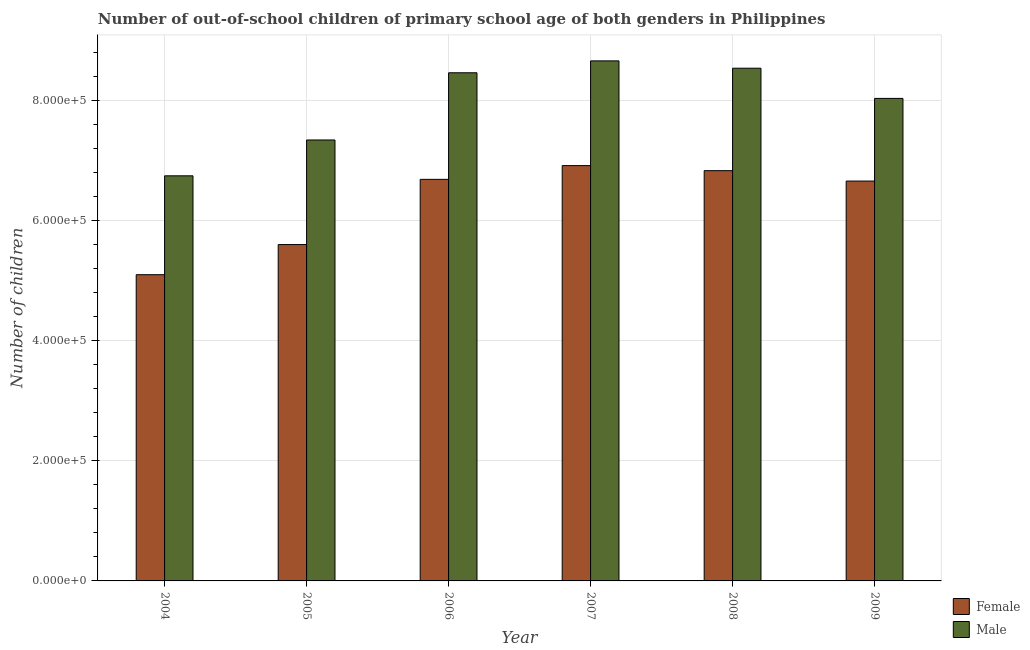How many different coloured bars are there?
Keep it short and to the point. 2. Are the number of bars per tick equal to the number of legend labels?
Provide a short and direct response. Yes. How many bars are there on the 2nd tick from the left?
Keep it short and to the point. 2. What is the number of female out-of-school students in 2004?
Offer a terse response. 5.10e+05. Across all years, what is the maximum number of male out-of-school students?
Offer a terse response. 8.66e+05. Across all years, what is the minimum number of male out-of-school students?
Offer a very short reply. 6.74e+05. In which year was the number of male out-of-school students maximum?
Provide a succinct answer. 2007. What is the total number of male out-of-school students in the graph?
Your answer should be compact. 4.78e+06. What is the difference between the number of male out-of-school students in 2004 and that in 2005?
Make the answer very short. -5.97e+04. What is the difference between the number of male out-of-school students in 2005 and the number of female out-of-school students in 2004?
Your answer should be compact. 5.97e+04. What is the average number of female out-of-school students per year?
Give a very brief answer. 6.30e+05. In how many years, is the number of male out-of-school students greater than 440000?
Your response must be concise. 6. What is the ratio of the number of male out-of-school students in 2004 to that in 2005?
Offer a very short reply. 0.92. Is the number of female out-of-school students in 2006 less than that in 2009?
Make the answer very short. No. What is the difference between the highest and the second highest number of female out-of-school students?
Keep it short and to the point. 8438. What is the difference between the highest and the lowest number of female out-of-school students?
Ensure brevity in your answer.  1.82e+05. Is the sum of the number of female out-of-school students in 2005 and 2009 greater than the maximum number of male out-of-school students across all years?
Your response must be concise. Yes. What does the 1st bar from the left in 2009 represents?
Your answer should be compact. Female. How many years are there in the graph?
Provide a short and direct response. 6. Are the values on the major ticks of Y-axis written in scientific E-notation?
Your response must be concise. Yes. Does the graph contain grids?
Your response must be concise. Yes. How many legend labels are there?
Provide a short and direct response. 2. How are the legend labels stacked?
Provide a succinct answer. Vertical. What is the title of the graph?
Your answer should be very brief. Number of out-of-school children of primary school age of both genders in Philippines. Does "Research and Development" appear as one of the legend labels in the graph?
Ensure brevity in your answer.  No. What is the label or title of the X-axis?
Provide a succinct answer. Year. What is the label or title of the Y-axis?
Your answer should be compact. Number of children. What is the Number of children in Female in 2004?
Your answer should be very brief. 5.10e+05. What is the Number of children in Male in 2004?
Offer a terse response. 6.74e+05. What is the Number of children of Female in 2005?
Your answer should be very brief. 5.60e+05. What is the Number of children in Male in 2005?
Offer a terse response. 7.34e+05. What is the Number of children in Female in 2006?
Your answer should be compact. 6.69e+05. What is the Number of children of Male in 2006?
Keep it short and to the point. 8.46e+05. What is the Number of children of Female in 2007?
Ensure brevity in your answer.  6.92e+05. What is the Number of children in Male in 2007?
Keep it short and to the point. 8.66e+05. What is the Number of children of Female in 2008?
Your answer should be very brief. 6.83e+05. What is the Number of children in Male in 2008?
Keep it short and to the point. 8.54e+05. What is the Number of children of Female in 2009?
Provide a succinct answer. 6.66e+05. What is the Number of children in Male in 2009?
Your response must be concise. 8.03e+05. Across all years, what is the maximum Number of children in Female?
Provide a succinct answer. 6.92e+05. Across all years, what is the maximum Number of children of Male?
Your answer should be very brief. 8.66e+05. Across all years, what is the minimum Number of children of Female?
Keep it short and to the point. 5.10e+05. Across all years, what is the minimum Number of children in Male?
Give a very brief answer. 6.74e+05. What is the total Number of children of Female in the graph?
Your answer should be very brief. 3.78e+06. What is the total Number of children of Male in the graph?
Provide a short and direct response. 4.78e+06. What is the difference between the Number of children of Female in 2004 and that in 2005?
Keep it short and to the point. -5.02e+04. What is the difference between the Number of children of Male in 2004 and that in 2005?
Your answer should be compact. -5.97e+04. What is the difference between the Number of children in Female in 2004 and that in 2006?
Provide a succinct answer. -1.59e+05. What is the difference between the Number of children in Male in 2004 and that in 2006?
Your answer should be very brief. -1.72e+05. What is the difference between the Number of children in Female in 2004 and that in 2007?
Make the answer very short. -1.82e+05. What is the difference between the Number of children of Male in 2004 and that in 2007?
Give a very brief answer. -1.91e+05. What is the difference between the Number of children of Female in 2004 and that in 2008?
Offer a terse response. -1.73e+05. What is the difference between the Number of children of Male in 2004 and that in 2008?
Offer a very short reply. -1.79e+05. What is the difference between the Number of children in Female in 2004 and that in 2009?
Your response must be concise. -1.56e+05. What is the difference between the Number of children in Male in 2004 and that in 2009?
Your answer should be very brief. -1.29e+05. What is the difference between the Number of children of Female in 2005 and that in 2006?
Make the answer very short. -1.09e+05. What is the difference between the Number of children of Male in 2005 and that in 2006?
Provide a short and direct response. -1.12e+05. What is the difference between the Number of children in Female in 2005 and that in 2007?
Offer a very short reply. -1.31e+05. What is the difference between the Number of children of Male in 2005 and that in 2007?
Provide a succinct answer. -1.32e+05. What is the difference between the Number of children of Female in 2005 and that in 2008?
Your response must be concise. -1.23e+05. What is the difference between the Number of children of Male in 2005 and that in 2008?
Keep it short and to the point. -1.20e+05. What is the difference between the Number of children of Female in 2005 and that in 2009?
Your answer should be compact. -1.06e+05. What is the difference between the Number of children in Male in 2005 and that in 2009?
Provide a succinct answer. -6.92e+04. What is the difference between the Number of children in Female in 2006 and that in 2007?
Provide a succinct answer. -2.29e+04. What is the difference between the Number of children in Male in 2006 and that in 2007?
Your answer should be compact. -1.98e+04. What is the difference between the Number of children of Female in 2006 and that in 2008?
Offer a terse response. -1.45e+04. What is the difference between the Number of children of Male in 2006 and that in 2008?
Provide a short and direct response. -7606. What is the difference between the Number of children in Female in 2006 and that in 2009?
Offer a terse response. 2822. What is the difference between the Number of children of Male in 2006 and that in 2009?
Provide a short and direct response. 4.26e+04. What is the difference between the Number of children of Female in 2007 and that in 2008?
Offer a very short reply. 8438. What is the difference between the Number of children in Male in 2007 and that in 2008?
Offer a very short reply. 1.22e+04. What is the difference between the Number of children of Female in 2007 and that in 2009?
Offer a terse response. 2.57e+04. What is the difference between the Number of children of Male in 2007 and that in 2009?
Make the answer very short. 6.25e+04. What is the difference between the Number of children in Female in 2008 and that in 2009?
Make the answer very short. 1.73e+04. What is the difference between the Number of children of Male in 2008 and that in 2009?
Offer a terse response. 5.03e+04. What is the difference between the Number of children of Female in 2004 and the Number of children of Male in 2005?
Make the answer very short. -2.24e+05. What is the difference between the Number of children in Female in 2004 and the Number of children in Male in 2006?
Provide a short and direct response. -3.36e+05. What is the difference between the Number of children in Female in 2004 and the Number of children in Male in 2007?
Provide a short and direct response. -3.56e+05. What is the difference between the Number of children of Female in 2004 and the Number of children of Male in 2008?
Give a very brief answer. -3.44e+05. What is the difference between the Number of children in Female in 2004 and the Number of children in Male in 2009?
Give a very brief answer. -2.94e+05. What is the difference between the Number of children in Female in 2005 and the Number of children in Male in 2006?
Make the answer very short. -2.86e+05. What is the difference between the Number of children of Female in 2005 and the Number of children of Male in 2007?
Offer a very short reply. -3.06e+05. What is the difference between the Number of children in Female in 2005 and the Number of children in Male in 2008?
Make the answer very short. -2.94e+05. What is the difference between the Number of children of Female in 2005 and the Number of children of Male in 2009?
Offer a very short reply. -2.43e+05. What is the difference between the Number of children of Female in 2006 and the Number of children of Male in 2007?
Provide a succinct answer. -1.97e+05. What is the difference between the Number of children in Female in 2006 and the Number of children in Male in 2008?
Your answer should be very brief. -1.85e+05. What is the difference between the Number of children in Female in 2006 and the Number of children in Male in 2009?
Your answer should be compact. -1.35e+05. What is the difference between the Number of children in Female in 2007 and the Number of children in Male in 2008?
Give a very brief answer. -1.62e+05. What is the difference between the Number of children of Female in 2007 and the Number of children of Male in 2009?
Your response must be concise. -1.12e+05. What is the difference between the Number of children of Female in 2008 and the Number of children of Male in 2009?
Your answer should be very brief. -1.20e+05. What is the average Number of children of Female per year?
Offer a very short reply. 6.30e+05. What is the average Number of children in Male per year?
Ensure brevity in your answer.  7.96e+05. In the year 2004, what is the difference between the Number of children of Female and Number of children of Male?
Offer a very short reply. -1.65e+05. In the year 2005, what is the difference between the Number of children of Female and Number of children of Male?
Ensure brevity in your answer.  -1.74e+05. In the year 2006, what is the difference between the Number of children of Female and Number of children of Male?
Offer a terse response. -1.77e+05. In the year 2007, what is the difference between the Number of children in Female and Number of children in Male?
Your answer should be very brief. -1.74e+05. In the year 2008, what is the difference between the Number of children of Female and Number of children of Male?
Keep it short and to the point. -1.71e+05. In the year 2009, what is the difference between the Number of children of Female and Number of children of Male?
Give a very brief answer. -1.38e+05. What is the ratio of the Number of children of Female in 2004 to that in 2005?
Provide a succinct answer. 0.91. What is the ratio of the Number of children of Male in 2004 to that in 2005?
Your response must be concise. 0.92. What is the ratio of the Number of children in Female in 2004 to that in 2006?
Offer a terse response. 0.76. What is the ratio of the Number of children in Male in 2004 to that in 2006?
Provide a succinct answer. 0.8. What is the ratio of the Number of children in Female in 2004 to that in 2007?
Offer a terse response. 0.74. What is the ratio of the Number of children of Male in 2004 to that in 2007?
Your answer should be compact. 0.78. What is the ratio of the Number of children in Female in 2004 to that in 2008?
Offer a terse response. 0.75. What is the ratio of the Number of children in Male in 2004 to that in 2008?
Make the answer very short. 0.79. What is the ratio of the Number of children of Female in 2004 to that in 2009?
Your answer should be very brief. 0.77. What is the ratio of the Number of children in Male in 2004 to that in 2009?
Your response must be concise. 0.84. What is the ratio of the Number of children of Female in 2005 to that in 2006?
Provide a succinct answer. 0.84. What is the ratio of the Number of children of Male in 2005 to that in 2006?
Give a very brief answer. 0.87. What is the ratio of the Number of children of Female in 2005 to that in 2007?
Your response must be concise. 0.81. What is the ratio of the Number of children of Male in 2005 to that in 2007?
Offer a very short reply. 0.85. What is the ratio of the Number of children in Female in 2005 to that in 2008?
Your answer should be compact. 0.82. What is the ratio of the Number of children in Male in 2005 to that in 2008?
Provide a short and direct response. 0.86. What is the ratio of the Number of children of Female in 2005 to that in 2009?
Offer a terse response. 0.84. What is the ratio of the Number of children in Male in 2005 to that in 2009?
Keep it short and to the point. 0.91. What is the ratio of the Number of children in Female in 2006 to that in 2007?
Provide a short and direct response. 0.97. What is the ratio of the Number of children of Male in 2006 to that in 2007?
Provide a short and direct response. 0.98. What is the ratio of the Number of children of Female in 2006 to that in 2008?
Your answer should be very brief. 0.98. What is the ratio of the Number of children in Male in 2006 to that in 2008?
Your answer should be compact. 0.99. What is the ratio of the Number of children of Male in 2006 to that in 2009?
Your response must be concise. 1.05. What is the ratio of the Number of children in Female in 2007 to that in 2008?
Give a very brief answer. 1.01. What is the ratio of the Number of children in Male in 2007 to that in 2008?
Ensure brevity in your answer.  1.01. What is the ratio of the Number of children of Female in 2007 to that in 2009?
Your answer should be compact. 1.04. What is the ratio of the Number of children of Male in 2007 to that in 2009?
Provide a short and direct response. 1.08. What is the ratio of the Number of children in Female in 2008 to that in 2009?
Ensure brevity in your answer.  1.03. What is the ratio of the Number of children of Male in 2008 to that in 2009?
Provide a short and direct response. 1.06. What is the difference between the highest and the second highest Number of children in Female?
Your answer should be compact. 8438. What is the difference between the highest and the second highest Number of children in Male?
Your answer should be very brief. 1.22e+04. What is the difference between the highest and the lowest Number of children of Female?
Ensure brevity in your answer.  1.82e+05. What is the difference between the highest and the lowest Number of children of Male?
Your answer should be very brief. 1.91e+05. 